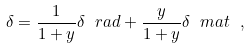<formula> <loc_0><loc_0><loc_500><loc_500>\delta = \frac { 1 } { 1 + y } \delta _ { \ } r a d + \frac { y } { 1 + y } \delta _ { \ } m a t \ ,</formula> 